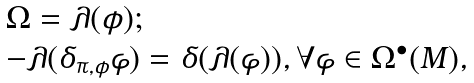Convert formula to latex. <formula><loc_0><loc_0><loc_500><loc_500>\begin{array} { l } \Omega = \lambda ( \phi ) ; \\ - \lambda ( \delta _ { \pi , \phi } \varphi ) = \delta ( \lambda ( \varphi ) ) , \forall \varphi \in \Omega ^ { \bullet } ( M ) , \end{array}</formula> 